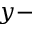<formula> <loc_0><loc_0><loc_500><loc_500>y -</formula> 